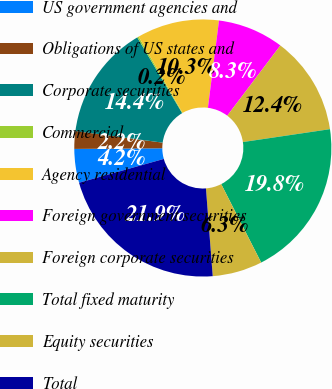Convert chart to OTSL. <chart><loc_0><loc_0><loc_500><loc_500><pie_chart><fcel>US government agencies and<fcel>Obligations of US states and<fcel>Corporate securities<fcel>Commercial<fcel>Agency residential<fcel>Foreign government securities<fcel>Foreign corporate securities<fcel>Total fixed maturity<fcel>Equity securities<fcel>Total<nl><fcel>4.24%<fcel>2.22%<fcel>14.38%<fcel>0.19%<fcel>10.33%<fcel>8.3%<fcel>12.35%<fcel>19.84%<fcel>6.27%<fcel>21.87%<nl></chart> 